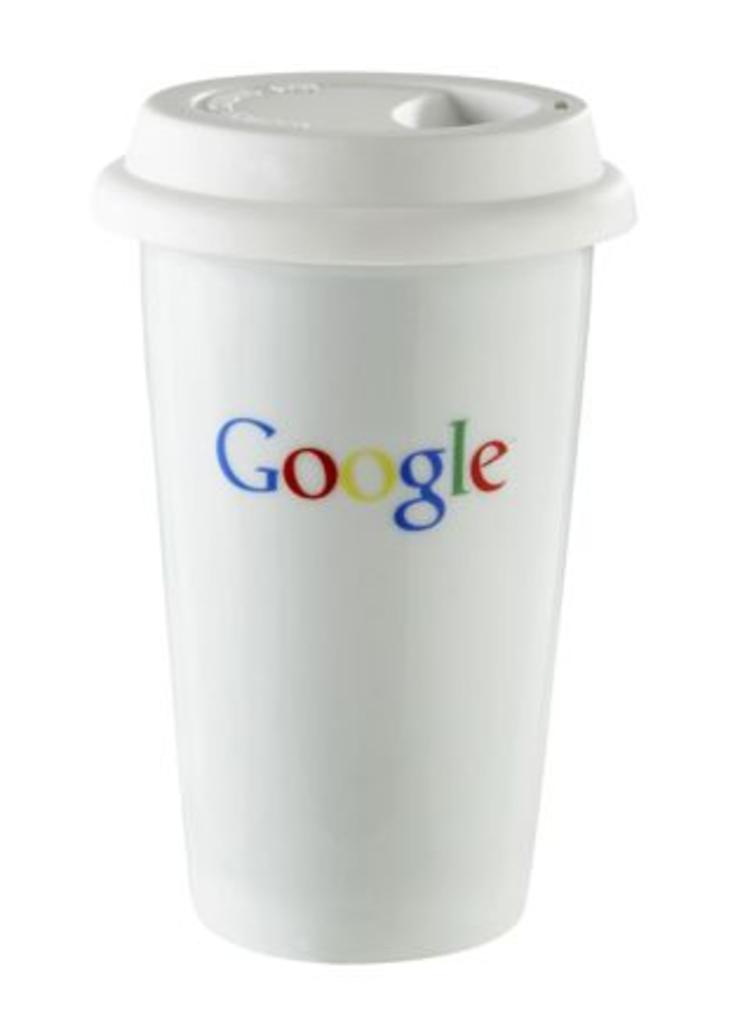What type of cup is visible in the image? There is a white cup in the image. Does the cup have any specific features? Yes, the cup has a lid. What brand or company is associated with the cup? There is a Google logo on the cup. How many eggs can be seen in the image? There are no eggs present in the image. What type of instrument is being played by the maid in the image? There is no maid or instrument present in the image. 